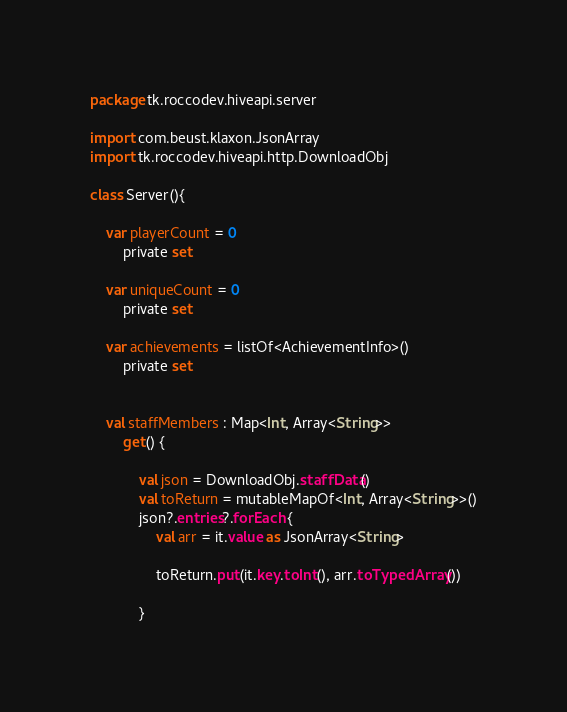Convert code to text. <code><loc_0><loc_0><loc_500><loc_500><_Kotlin_>package tk.roccodev.hiveapi.server

import com.beust.klaxon.JsonArray
import tk.roccodev.hiveapi.http.DownloadObj

class Server(){

    var playerCount = 0
        private set

    var uniqueCount = 0
        private set

    var achievements = listOf<AchievementInfo>()
        private set


    val staffMembers : Map<Int, Array<String>>
        get() {

            val json = DownloadObj.staffData()
            val toReturn = mutableMapOf<Int, Array<String>>()
            json?.entries?.forEach {
                val arr = it.value as JsonArray<String>

                toReturn.put(it.key.toInt(), arr.toTypedArray())

            }</code> 